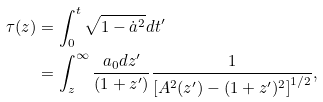<formula> <loc_0><loc_0><loc_500><loc_500>\tau ( z ) & = \int _ { 0 } ^ { t } \sqrt { 1 - \dot { a } ^ { 2 } } d t ^ { \prime } \\ & = \int _ { z } ^ { \infty } \frac { a _ { 0 } d z ^ { \prime } } { ( 1 + z ^ { \prime } ) } \frac { 1 } { \left [ A ^ { 2 } ( z ^ { \prime } ) - ( 1 + z ^ { \prime } ) ^ { 2 } \right ] ^ { 1 / 2 } } ,</formula> 